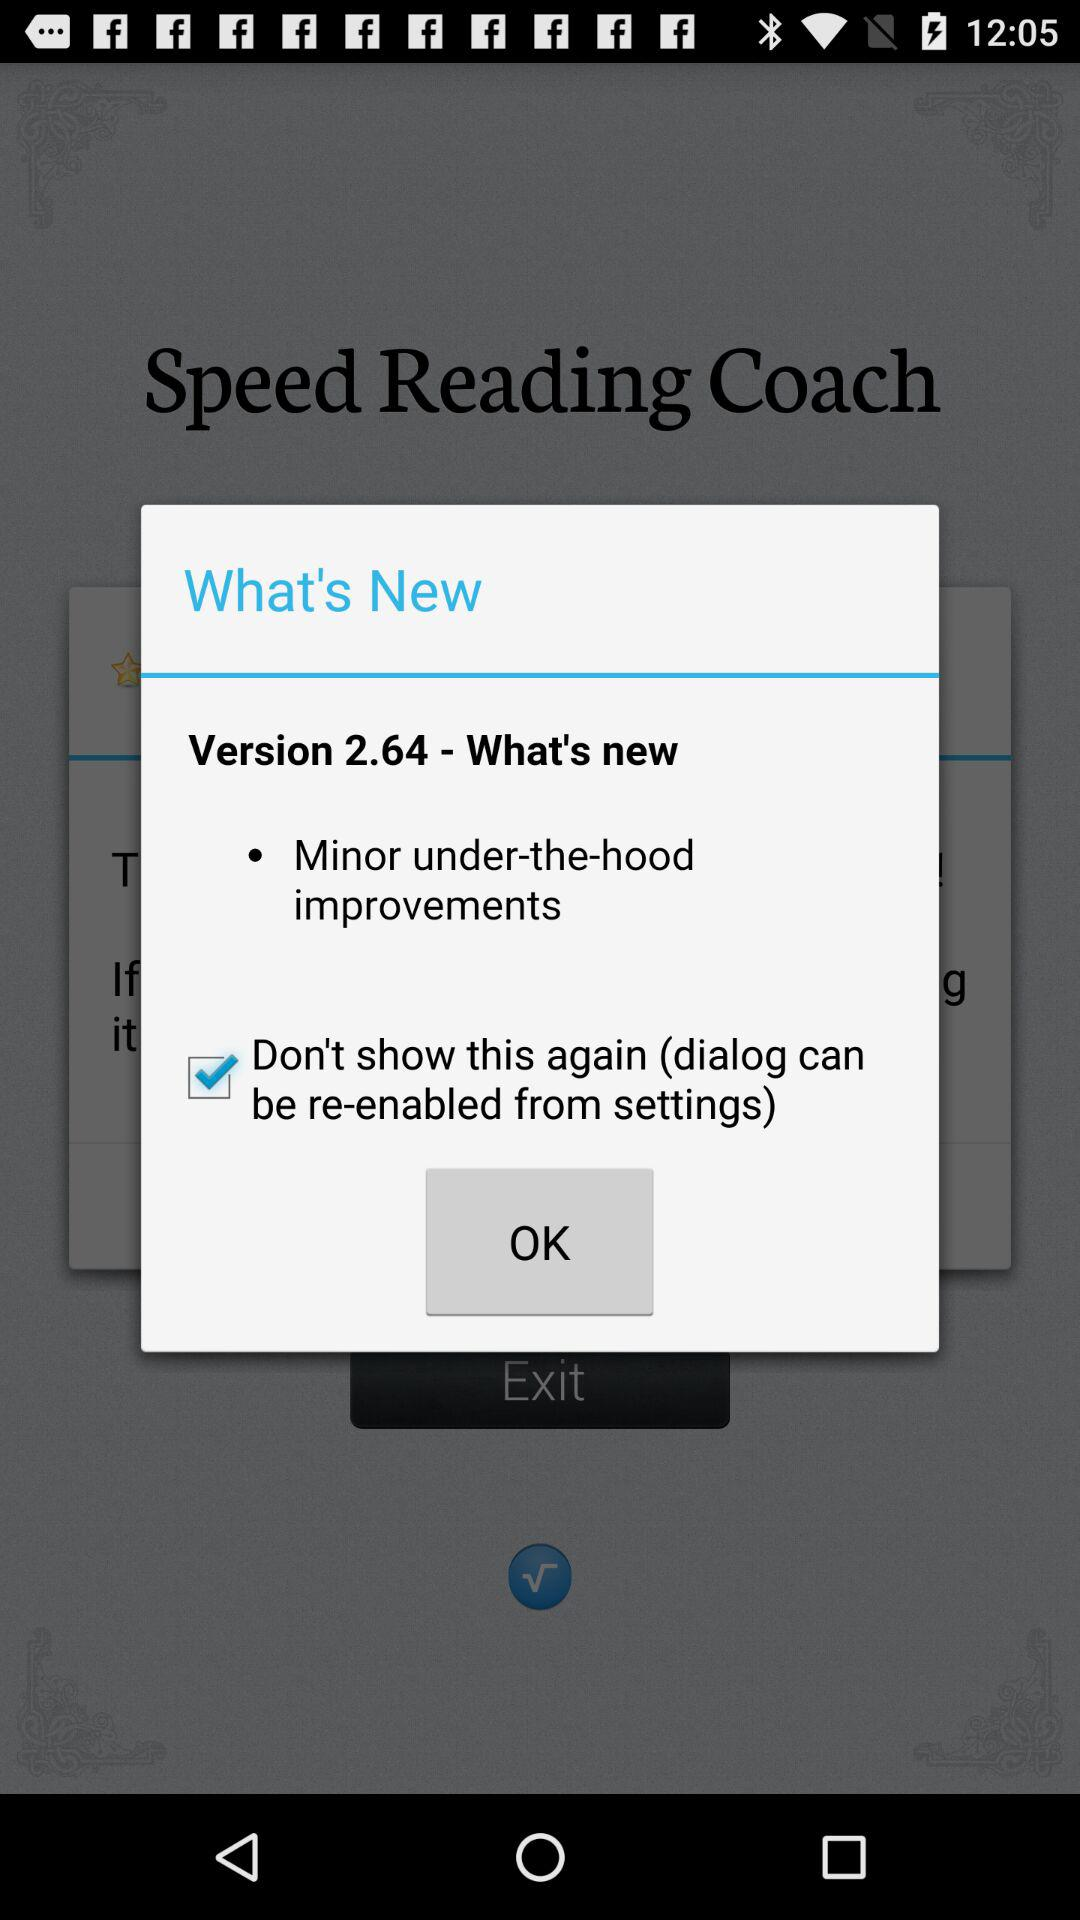What is the latest update in version 2.64? The latest update is "Minor under-the-hood improvements". 